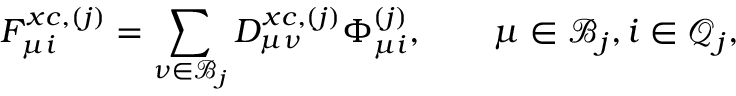<formula> <loc_0><loc_0><loc_500><loc_500>F _ { \mu i } ^ { x c , ( j ) } = \sum _ { \nu \in \mathcal { B } _ { j } } D _ { \mu \nu } ^ { x c , ( j ) } \Phi _ { \mu i } ^ { ( j ) } , \quad \mu \in \mathcal { B } _ { j } , i \in \mathcal { Q } _ { j } ,</formula> 